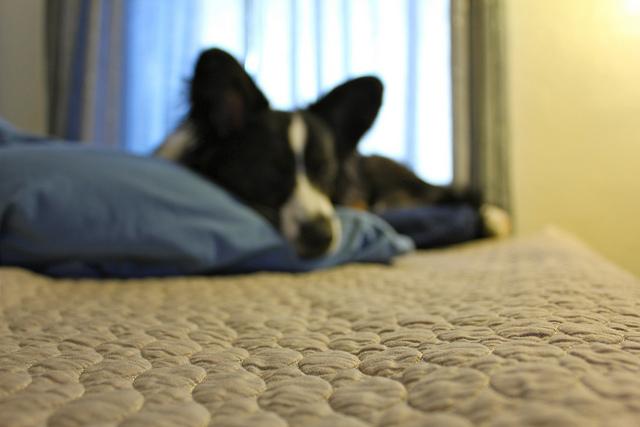Is this dog alert?
Quick response, please. No. What color pillow is the dog laying on?
Answer briefly. Blue. What part object is in focus?
Answer briefly. Mattress. What is the dog looking at?
Keep it brief. Camera. What color is the dog?
Give a very brief answer. Black and white. 